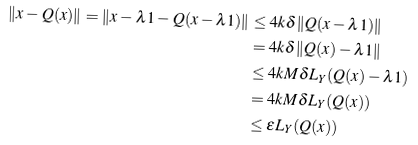Convert formula to latex. <formula><loc_0><loc_0><loc_500><loc_500>\| x - Q ( x ) \| = \| x - \lambda 1 - Q ( x - \lambda 1 ) \| & \leq 4 k \delta \| Q ( x - \lambda 1 ) \| \\ & = 4 k \delta \| Q ( x ) - \lambda 1 \| \\ & \leq 4 k M \delta L _ { Y } ( Q ( x ) - \lambda 1 ) \\ & = 4 k M \delta L _ { Y } ( Q ( x ) ) \\ & \leq \epsilon L _ { Y } ( Q ( x ) )</formula> 